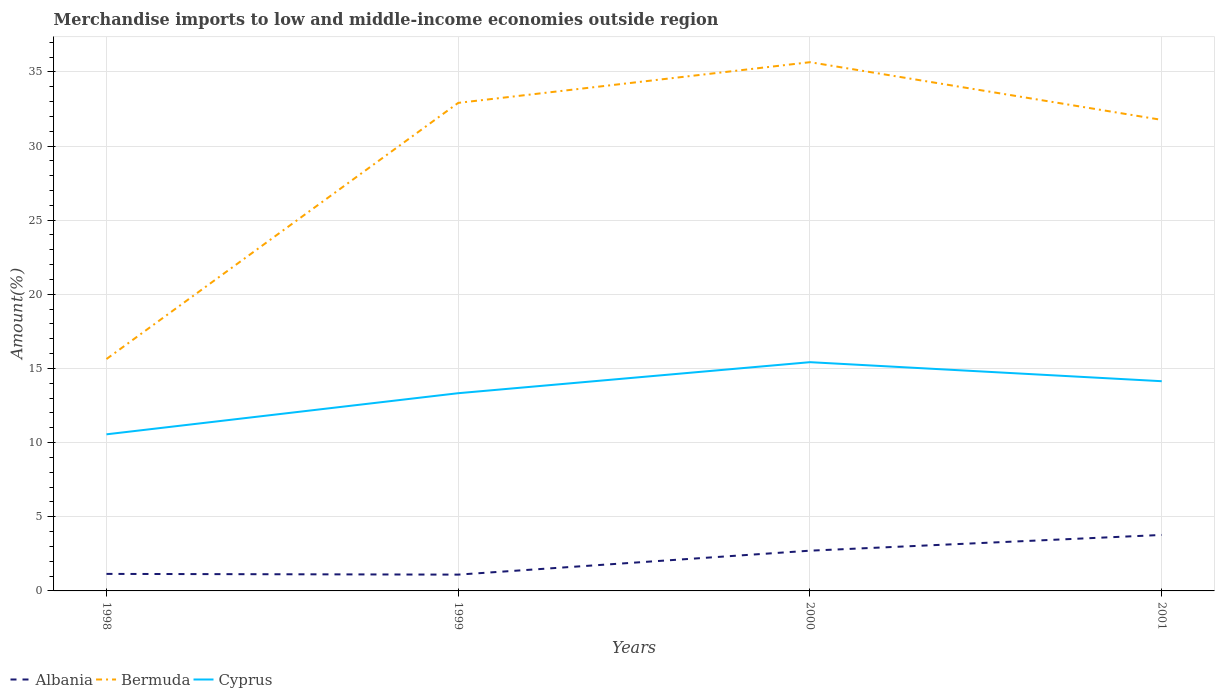Does the line corresponding to Bermuda intersect with the line corresponding to Cyprus?
Keep it short and to the point. No. Across all years, what is the maximum percentage of amount earned from merchandise imports in Bermuda?
Your response must be concise. 15.64. What is the total percentage of amount earned from merchandise imports in Bermuda in the graph?
Offer a very short reply. 1.15. What is the difference between the highest and the second highest percentage of amount earned from merchandise imports in Bermuda?
Your answer should be very brief. 20.01. What is the difference between the highest and the lowest percentage of amount earned from merchandise imports in Albania?
Provide a succinct answer. 2. How many lines are there?
Your answer should be compact. 3. How many years are there in the graph?
Ensure brevity in your answer.  4. What is the difference between two consecutive major ticks on the Y-axis?
Your answer should be compact. 5. Where does the legend appear in the graph?
Give a very brief answer. Bottom left. How are the legend labels stacked?
Your answer should be compact. Horizontal. What is the title of the graph?
Your response must be concise. Merchandise imports to low and middle-income economies outside region. Does "Malawi" appear as one of the legend labels in the graph?
Keep it short and to the point. No. What is the label or title of the Y-axis?
Make the answer very short. Amount(%). What is the Amount(%) of Albania in 1998?
Offer a very short reply. 1.15. What is the Amount(%) in Bermuda in 1998?
Ensure brevity in your answer.  15.64. What is the Amount(%) in Cyprus in 1998?
Provide a short and direct response. 10.56. What is the Amount(%) in Albania in 1999?
Your response must be concise. 1.1. What is the Amount(%) in Bermuda in 1999?
Offer a terse response. 32.91. What is the Amount(%) of Cyprus in 1999?
Provide a succinct answer. 13.33. What is the Amount(%) in Albania in 2000?
Your answer should be compact. 2.71. What is the Amount(%) in Bermuda in 2000?
Make the answer very short. 35.65. What is the Amount(%) of Cyprus in 2000?
Give a very brief answer. 15.42. What is the Amount(%) in Albania in 2001?
Ensure brevity in your answer.  3.77. What is the Amount(%) in Bermuda in 2001?
Give a very brief answer. 31.76. What is the Amount(%) in Cyprus in 2001?
Give a very brief answer. 14.14. Across all years, what is the maximum Amount(%) of Albania?
Provide a succinct answer. 3.77. Across all years, what is the maximum Amount(%) of Bermuda?
Your answer should be compact. 35.65. Across all years, what is the maximum Amount(%) in Cyprus?
Provide a succinct answer. 15.42. Across all years, what is the minimum Amount(%) in Albania?
Give a very brief answer. 1.1. Across all years, what is the minimum Amount(%) of Bermuda?
Offer a very short reply. 15.64. Across all years, what is the minimum Amount(%) of Cyprus?
Provide a succinct answer. 10.56. What is the total Amount(%) in Albania in the graph?
Offer a very short reply. 8.74. What is the total Amount(%) in Bermuda in the graph?
Your response must be concise. 115.96. What is the total Amount(%) in Cyprus in the graph?
Offer a terse response. 53.46. What is the difference between the Amount(%) in Albania in 1998 and that in 1999?
Offer a terse response. 0.05. What is the difference between the Amount(%) in Bermuda in 1998 and that in 1999?
Ensure brevity in your answer.  -17.27. What is the difference between the Amount(%) in Cyprus in 1998 and that in 1999?
Provide a succinct answer. -2.77. What is the difference between the Amount(%) of Albania in 1998 and that in 2000?
Your response must be concise. -1.57. What is the difference between the Amount(%) of Bermuda in 1998 and that in 2000?
Ensure brevity in your answer.  -20.01. What is the difference between the Amount(%) of Cyprus in 1998 and that in 2000?
Offer a terse response. -4.86. What is the difference between the Amount(%) in Albania in 1998 and that in 2001?
Give a very brief answer. -2.63. What is the difference between the Amount(%) of Bermuda in 1998 and that in 2001?
Your answer should be compact. -16.12. What is the difference between the Amount(%) in Cyprus in 1998 and that in 2001?
Offer a very short reply. -3.58. What is the difference between the Amount(%) in Albania in 1999 and that in 2000?
Ensure brevity in your answer.  -1.61. What is the difference between the Amount(%) in Bermuda in 1999 and that in 2000?
Provide a short and direct response. -2.74. What is the difference between the Amount(%) of Cyprus in 1999 and that in 2000?
Your answer should be compact. -2.09. What is the difference between the Amount(%) of Albania in 1999 and that in 2001?
Keep it short and to the point. -2.68. What is the difference between the Amount(%) in Bermuda in 1999 and that in 2001?
Your answer should be very brief. 1.15. What is the difference between the Amount(%) of Cyprus in 1999 and that in 2001?
Make the answer very short. -0.81. What is the difference between the Amount(%) in Albania in 2000 and that in 2001?
Provide a short and direct response. -1.06. What is the difference between the Amount(%) of Bermuda in 2000 and that in 2001?
Offer a very short reply. 3.89. What is the difference between the Amount(%) of Cyprus in 2000 and that in 2001?
Offer a terse response. 1.28. What is the difference between the Amount(%) in Albania in 1998 and the Amount(%) in Bermuda in 1999?
Your answer should be very brief. -31.76. What is the difference between the Amount(%) in Albania in 1998 and the Amount(%) in Cyprus in 1999?
Provide a succinct answer. -12.18. What is the difference between the Amount(%) of Bermuda in 1998 and the Amount(%) of Cyprus in 1999?
Offer a terse response. 2.3. What is the difference between the Amount(%) in Albania in 1998 and the Amount(%) in Bermuda in 2000?
Your answer should be compact. -34.5. What is the difference between the Amount(%) in Albania in 1998 and the Amount(%) in Cyprus in 2000?
Provide a succinct answer. -14.28. What is the difference between the Amount(%) in Bermuda in 1998 and the Amount(%) in Cyprus in 2000?
Give a very brief answer. 0.21. What is the difference between the Amount(%) of Albania in 1998 and the Amount(%) of Bermuda in 2001?
Ensure brevity in your answer.  -30.61. What is the difference between the Amount(%) of Albania in 1998 and the Amount(%) of Cyprus in 2001?
Give a very brief answer. -12.99. What is the difference between the Amount(%) of Bermuda in 1998 and the Amount(%) of Cyprus in 2001?
Your response must be concise. 1.5. What is the difference between the Amount(%) of Albania in 1999 and the Amount(%) of Bermuda in 2000?
Provide a short and direct response. -34.55. What is the difference between the Amount(%) of Albania in 1999 and the Amount(%) of Cyprus in 2000?
Your response must be concise. -14.32. What is the difference between the Amount(%) of Bermuda in 1999 and the Amount(%) of Cyprus in 2000?
Offer a very short reply. 17.48. What is the difference between the Amount(%) of Albania in 1999 and the Amount(%) of Bermuda in 2001?
Your answer should be compact. -30.66. What is the difference between the Amount(%) in Albania in 1999 and the Amount(%) in Cyprus in 2001?
Offer a very short reply. -13.04. What is the difference between the Amount(%) of Bermuda in 1999 and the Amount(%) of Cyprus in 2001?
Offer a very short reply. 18.77. What is the difference between the Amount(%) of Albania in 2000 and the Amount(%) of Bermuda in 2001?
Offer a very short reply. -29.05. What is the difference between the Amount(%) of Albania in 2000 and the Amount(%) of Cyprus in 2001?
Give a very brief answer. -11.43. What is the difference between the Amount(%) in Bermuda in 2000 and the Amount(%) in Cyprus in 2001?
Your response must be concise. 21.51. What is the average Amount(%) in Albania per year?
Your answer should be compact. 2.18. What is the average Amount(%) in Bermuda per year?
Make the answer very short. 28.99. What is the average Amount(%) in Cyprus per year?
Your answer should be compact. 13.36. In the year 1998, what is the difference between the Amount(%) in Albania and Amount(%) in Bermuda?
Your answer should be compact. -14.49. In the year 1998, what is the difference between the Amount(%) in Albania and Amount(%) in Cyprus?
Offer a very short reply. -9.41. In the year 1998, what is the difference between the Amount(%) in Bermuda and Amount(%) in Cyprus?
Your response must be concise. 5.08. In the year 1999, what is the difference between the Amount(%) of Albania and Amount(%) of Bermuda?
Offer a very short reply. -31.81. In the year 1999, what is the difference between the Amount(%) in Albania and Amount(%) in Cyprus?
Offer a very short reply. -12.23. In the year 1999, what is the difference between the Amount(%) of Bermuda and Amount(%) of Cyprus?
Provide a short and direct response. 19.58. In the year 2000, what is the difference between the Amount(%) of Albania and Amount(%) of Bermuda?
Offer a terse response. -32.94. In the year 2000, what is the difference between the Amount(%) in Albania and Amount(%) in Cyprus?
Your answer should be very brief. -12.71. In the year 2000, what is the difference between the Amount(%) in Bermuda and Amount(%) in Cyprus?
Ensure brevity in your answer.  20.23. In the year 2001, what is the difference between the Amount(%) of Albania and Amount(%) of Bermuda?
Ensure brevity in your answer.  -27.99. In the year 2001, what is the difference between the Amount(%) of Albania and Amount(%) of Cyprus?
Ensure brevity in your answer.  -10.37. In the year 2001, what is the difference between the Amount(%) in Bermuda and Amount(%) in Cyprus?
Ensure brevity in your answer.  17.62. What is the ratio of the Amount(%) in Albania in 1998 to that in 1999?
Give a very brief answer. 1.04. What is the ratio of the Amount(%) in Bermuda in 1998 to that in 1999?
Provide a succinct answer. 0.48. What is the ratio of the Amount(%) in Cyprus in 1998 to that in 1999?
Your response must be concise. 0.79. What is the ratio of the Amount(%) in Albania in 1998 to that in 2000?
Offer a very short reply. 0.42. What is the ratio of the Amount(%) in Bermuda in 1998 to that in 2000?
Your response must be concise. 0.44. What is the ratio of the Amount(%) of Cyprus in 1998 to that in 2000?
Your response must be concise. 0.68. What is the ratio of the Amount(%) in Albania in 1998 to that in 2001?
Provide a succinct answer. 0.3. What is the ratio of the Amount(%) of Bermuda in 1998 to that in 2001?
Your response must be concise. 0.49. What is the ratio of the Amount(%) in Cyprus in 1998 to that in 2001?
Your answer should be compact. 0.75. What is the ratio of the Amount(%) of Albania in 1999 to that in 2000?
Provide a short and direct response. 0.41. What is the ratio of the Amount(%) in Cyprus in 1999 to that in 2000?
Your response must be concise. 0.86. What is the ratio of the Amount(%) of Albania in 1999 to that in 2001?
Your response must be concise. 0.29. What is the ratio of the Amount(%) of Bermuda in 1999 to that in 2001?
Give a very brief answer. 1.04. What is the ratio of the Amount(%) in Cyprus in 1999 to that in 2001?
Provide a short and direct response. 0.94. What is the ratio of the Amount(%) of Albania in 2000 to that in 2001?
Your answer should be very brief. 0.72. What is the ratio of the Amount(%) of Bermuda in 2000 to that in 2001?
Keep it short and to the point. 1.12. What is the ratio of the Amount(%) in Cyprus in 2000 to that in 2001?
Your answer should be compact. 1.09. What is the difference between the highest and the second highest Amount(%) of Albania?
Provide a succinct answer. 1.06. What is the difference between the highest and the second highest Amount(%) in Bermuda?
Your answer should be compact. 2.74. What is the difference between the highest and the second highest Amount(%) of Cyprus?
Keep it short and to the point. 1.28. What is the difference between the highest and the lowest Amount(%) of Albania?
Offer a very short reply. 2.68. What is the difference between the highest and the lowest Amount(%) in Bermuda?
Provide a succinct answer. 20.01. What is the difference between the highest and the lowest Amount(%) in Cyprus?
Your answer should be compact. 4.86. 